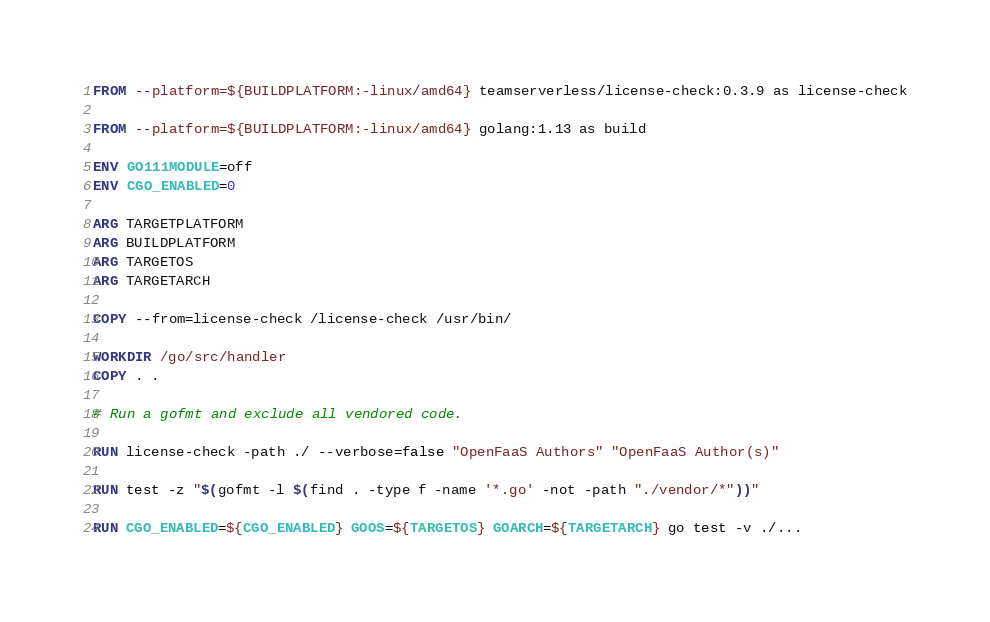<code> <loc_0><loc_0><loc_500><loc_500><_Dockerfile_>FROM --platform=${BUILDPLATFORM:-linux/amd64} teamserverless/license-check:0.3.9 as license-check

FROM --platform=${BUILDPLATFORM:-linux/amd64} golang:1.13 as build

ENV GO111MODULE=off
ENV CGO_ENABLED=0

ARG TARGETPLATFORM
ARG BUILDPLATFORM
ARG TARGETOS
ARG TARGETARCH

COPY --from=license-check /license-check /usr/bin/

WORKDIR /go/src/handler
COPY . .

# Run a gofmt and exclude all vendored code.

RUN license-check -path ./ --verbose=false "OpenFaaS Authors" "OpenFaaS Author(s)"

RUN test -z "$(gofmt -l $(find . -type f -name '*.go' -not -path "./vendor/*"))"

RUN CGO_ENABLED=${CGO_ENABLED} GOOS=${TARGETOS} GOARCH=${TARGETARCH} go test -v ./...
</code> 